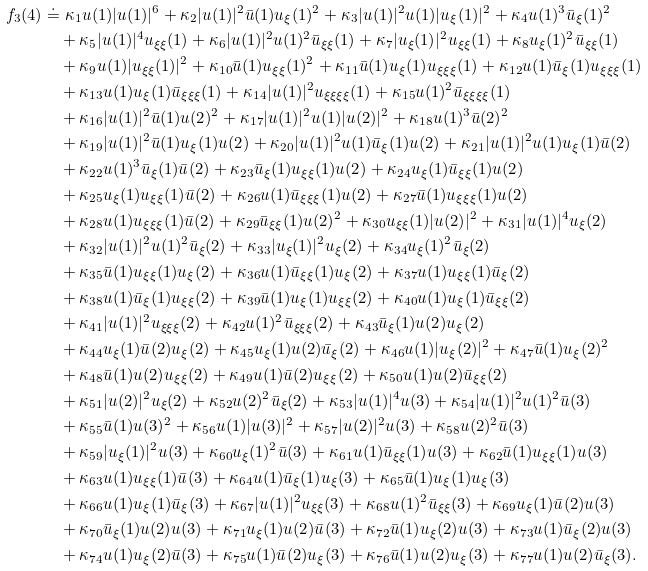<formula> <loc_0><loc_0><loc_500><loc_500>f _ { 3 } ( 4 ) & \doteq \kappa _ { 1 } u ( 1 ) | u ( 1 ) | ^ { 6 } + \kappa _ { 2 } | u ( 1 ) | ^ { 2 } \bar { u } ( 1 ) u _ { \xi } ( 1 ) ^ { 2 } + \kappa _ { 3 } | u ( 1 ) | ^ { 2 } u ( 1 ) | u _ { \xi } ( 1 ) | ^ { 2 } + \kappa _ { 4 } u ( 1 ) ^ { 3 } \bar { u } _ { \xi } ( 1 ) ^ { 2 } \\ & \quad + \kappa _ { 5 } | u ( 1 ) | ^ { 4 } u _ { \xi \xi } ( 1 ) + \kappa _ { 6 } | u ( 1 ) | ^ { 2 } u ( 1 ) ^ { 2 } \bar { u } _ { \xi \xi } ( 1 ) + \kappa _ { 7 } | u _ { \xi } ( 1 ) | ^ { 2 } u _ { \xi \xi } ( 1 ) + \kappa _ { 8 } u _ { \xi } ( 1 ) ^ { 2 } \bar { u } _ { \xi \xi } ( 1 ) \\ & \quad + \kappa _ { 9 } u ( 1 ) | u _ { \xi \xi } ( 1 ) | ^ { 2 } + \kappa _ { 1 0 } \bar { u } ( 1 ) u _ { \xi \xi } ( 1 ) ^ { 2 } + \kappa _ { 1 1 } \bar { u } ( 1 ) u _ { \xi } ( 1 ) u _ { \xi \xi \xi } ( 1 ) + \kappa _ { 1 2 } u ( 1 ) \bar { u } _ { \xi } ( 1 ) u _ { \xi \xi \xi } ( 1 ) \\ & \quad + \kappa _ { 1 3 } u ( 1 ) u _ { \xi } ( 1 ) \bar { u } _ { \xi \xi \xi } ( 1 ) + \kappa _ { 1 4 } | u ( 1 ) | ^ { 2 } u _ { \xi \xi \xi \xi } ( 1 ) + \kappa _ { 1 5 } u ( 1 ) ^ { 2 } \bar { u } _ { \xi \xi \xi \xi } ( 1 ) \\ & \quad + \kappa _ { 1 6 } | u ( 1 ) | ^ { 2 } \bar { u } ( 1 ) u ( 2 ) ^ { 2 } + \kappa _ { 1 7 } | u ( 1 ) | ^ { 2 } u ( 1 ) | u ( 2 ) | ^ { 2 } + \kappa _ { 1 8 } u ( 1 ) ^ { 3 } \bar { u } ( 2 ) ^ { 2 } \\ & \quad + \kappa _ { 1 9 } | u ( 1 ) | ^ { 2 } \bar { u } ( 1 ) u _ { \xi } ( 1 ) u ( 2 ) + \kappa _ { 2 0 } | u ( 1 ) | ^ { 2 } u ( 1 ) \bar { u } _ { \xi } ( 1 ) u ( 2 ) + \kappa _ { 2 1 } | u ( 1 ) | ^ { 2 } u ( 1 ) u _ { \xi } ( 1 ) \bar { u } ( 2 ) \\ & \quad + \kappa _ { 2 2 } u ( 1 ) ^ { 3 } \bar { u } _ { \xi } ( 1 ) \bar { u } ( 2 ) + \kappa _ { 2 3 } \bar { u } _ { \xi } ( 1 ) u _ { \xi \xi } ( 1 ) u ( 2 ) + \kappa _ { 2 4 } u _ { \xi } ( 1 ) \bar { u } _ { \xi \xi } ( 1 ) u ( 2 ) \\ & \quad + \kappa _ { 2 5 } u _ { \xi } ( 1 ) u _ { \xi \xi } ( 1 ) \bar { u } ( 2 ) + \kappa _ { 2 6 } u ( 1 ) \bar { u } _ { \xi \xi \xi } ( 1 ) u ( 2 ) + \kappa _ { 2 7 } \bar { u } ( 1 ) u _ { \xi \xi \xi } ( 1 ) u ( 2 ) \\ & \quad + \kappa _ { 2 8 } u ( 1 ) u _ { \xi \xi \xi } ( 1 ) \bar { u } ( 2 ) + \kappa _ { 2 9 } \bar { u } _ { \xi \xi } ( 1 ) u ( 2 ) ^ { 2 } + \kappa _ { 3 0 } u _ { \xi \xi } ( 1 ) | u ( 2 ) | ^ { 2 } + \kappa _ { 3 1 } | u ( 1 ) | ^ { 4 } u _ { \xi } ( 2 ) \\ & \quad + \kappa _ { 3 2 } | u ( 1 ) | ^ { 2 } u ( 1 ) ^ { 2 } \bar { u } _ { \xi } ( 2 ) + \kappa _ { 3 3 } | u _ { \xi } ( 1 ) | ^ { 2 } u _ { \xi } ( 2 ) + \kappa _ { 3 4 } u _ { \xi } ( 1 ) ^ { 2 } \bar { u } _ { \xi } ( 2 ) \\ & \quad + \kappa _ { 3 5 } \bar { u } ( 1 ) u _ { \xi \xi } ( 1 ) u _ { \xi } ( 2 ) + \kappa _ { 3 6 } u ( 1 ) \bar { u } _ { \xi \xi } ( 1 ) u _ { \xi } ( 2 ) + \kappa _ { 3 7 } u ( 1 ) u _ { \xi \xi } ( 1 ) \bar { u } _ { \xi } ( 2 ) \\ & \quad + \kappa _ { 3 8 } u ( 1 ) \bar { u } _ { \xi } ( 1 ) u _ { \xi \xi } ( 2 ) + \kappa _ { 3 9 } \bar { u } ( 1 ) u _ { \xi } ( 1 ) u _ { \xi \xi } ( 2 ) + \kappa _ { 4 0 } u ( 1 ) u _ { \xi } ( 1 ) \bar { u } _ { \xi \xi } ( 2 ) \\ & \quad + \kappa _ { 4 1 } | u ( 1 ) | ^ { 2 } u _ { \xi \xi \xi } ( 2 ) + \kappa _ { 4 2 } u ( 1 ) ^ { 2 } \bar { u } _ { \xi \xi \xi } ( 2 ) + \kappa _ { 4 3 } \bar { u } _ { \xi } ( 1 ) u ( 2 ) u _ { \xi } ( 2 ) \\ & \quad + \kappa _ { 4 4 } u _ { \xi } ( 1 ) \bar { u } ( 2 ) u _ { \xi } ( 2 ) + \kappa _ { 4 5 } u _ { \xi } ( 1 ) u ( 2 ) \bar { u } _ { \xi } ( 2 ) + \kappa _ { 4 6 } u ( 1 ) | u _ { \xi } ( 2 ) | ^ { 2 } + \kappa _ { 4 7 } \bar { u } ( 1 ) u _ { \xi } ( 2 ) ^ { 2 } \\ & \quad + \kappa _ { 4 8 } \bar { u } ( 1 ) u ( 2 ) u _ { \xi \xi } ( 2 ) + \kappa _ { 4 9 } u ( 1 ) \bar { u } ( 2 ) u _ { \xi \xi } ( 2 ) + \kappa _ { 5 0 } u ( 1 ) u ( 2 ) \bar { u } _ { \xi \xi } ( 2 ) \\ & \quad + \kappa _ { 5 1 } | u ( 2 ) | ^ { 2 } u _ { \xi } ( 2 ) + \kappa _ { 5 2 } u ( 2 ) ^ { 2 } \bar { u } _ { \xi } ( 2 ) + \kappa _ { 5 3 } | u ( 1 ) | ^ { 4 } u ( 3 ) + \kappa _ { 5 4 } | u ( 1 ) | ^ { 2 } u ( 1 ) ^ { 2 } \bar { u } ( 3 ) \\ & \quad + \kappa _ { 5 5 } \bar { u } ( 1 ) u ( 3 ) ^ { 2 } + \kappa _ { 5 6 } u ( 1 ) | u ( 3 ) | ^ { 2 } + \kappa _ { 5 7 } | u ( 2 ) | ^ { 2 } u ( 3 ) + \kappa _ { 5 8 } u ( 2 ) ^ { 2 } \bar { u } ( 3 ) \\ & \quad + \kappa _ { 5 9 } | u _ { \xi } ( 1 ) | ^ { 2 } u ( 3 ) + \kappa _ { 6 0 } u _ { \xi } ( 1 ) ^ { 2 } \bar { u } ( 3 ) + \kappa _ { 6 1 } u ( 1 ) \bar { u } _ { \xi \xi } ( 1 ) u ( 3 ) + \kappa _ { 6 2 } \bar { u } ( 1 ) u _ { \xi \xi } ( 1 ) u ( 3 ) \\ & \quad + \kappa _ { 6 3 } u ( 1 ) u _ { \xi \xi } ( 1 ) \bar { u } ( 3 ) + \kappa _ { 6 4 } u ( 1 ) \bar { u } _ { \xi } ( 1 ) u _ { \xi } ( 3 ) + \kappa _ { 6 5 } \bar { u } ( 1 ) u _ { \xi } ( 1 ) u _ { \xi } ( 3 ) \\ & \quad + \kappa _ { 6 6 } u ( 1 ) u _ { \xi } ( 1 ) \bar { u } _ { \xi } ( 3 ) + \kappa _ { 6 7 } | u ( 1 ) | ^ { 2 } u _ { \xi \xi } ( 3 ) + \kappa _ { 6 8 } u ( 1 ) ^ { 2 } \bar { u } _ { \xi \xi } ( 3 ) + \kappa _ { 6 9 } u _ { \xi } ( 1 ) \bar { u } ( 2 ) u ( 3 ) \\ & \quad + \kappa _ { 7 0 } \bar { u } _ { \xi } ( 1 ) u ( 2 ) u ( 3 ) + \kappa _ { 7 1 } u _ { \xi } ( 1 ) u ( 2 ) \bar { u } ( 3 ) + \kappa _ { 7 2 } \bar { u } ( 1 ) u _ { \xi } ( 2 ) u ( 3 ) + \kappa _ { 7 3 } u ( 1 ) \bar { u } _ { \xi } ( 2 ) u ( 3 ) \\ & \quad + \kappa _ { 7 4 } u ( 1 ) u _ { \xi } ( 2 ) \bar { u } ( 3 ) + \kappa _ { 7 5 } u ( 1 ) \bar { u } ( 2 ) u _ { \xi } ( 3 ) + \kappa _ { 7 6 } \bar { u } ( 1 ) u ( 2 ) u _ { \xi } ( 3 ) + \kappa _ { 7 7 } u ( 1 ) u ( 2 ) \bar { u } _ { \xi } ( 3 ) .</formula> 